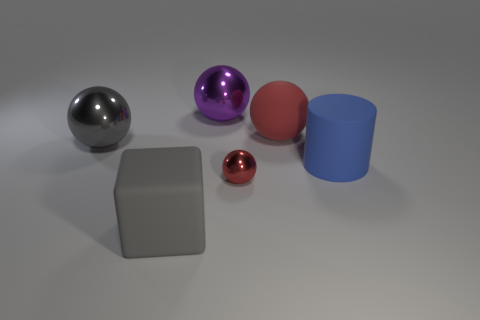Add 2 spheres. How many objects exist? 8 Subtract all cubes. How many objects are left? 5 Subtract all small blue rubber cubes. Subtract all blue cylinders. How many objects are left? 5 Add 2 big purple shiny spheres. How many big purple shiny spheres are left? 3 Add 6 tiny red shiny blocks. How many tiny red shiny blocks exist? 6 Subtract 0 green blocks. How many objects are left? 6 